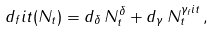Convert formula to latex. <formula><loc_0><loc_0><loc_500><loc_500>d _ { f } i t ( N _ { t } ) = d _ { \delta } \, N _ { t } ^ { \delta } + d _ { \gamma } \, N _ { t } ^ { \gamma _ { f } i t } \, ,</formula> 